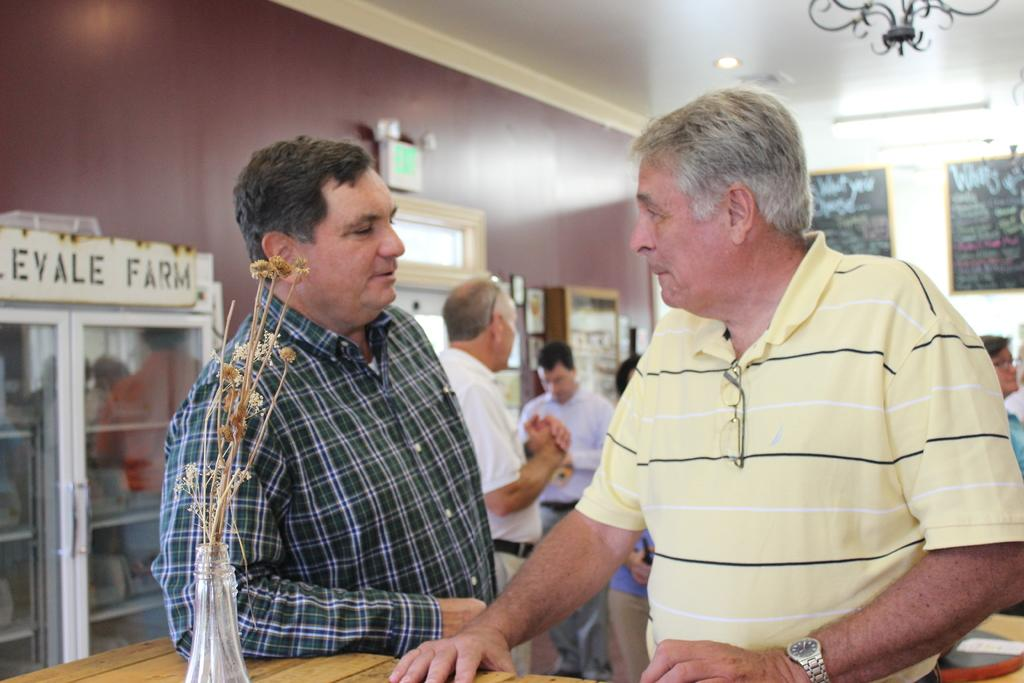How many men are in the foreground of the image? There are two men standing in the foreground of the image. What can be seen on a table in the image? There is an object on a table in the image. What is visible in the background of the image? In the background of the image, there are people, posters, light, showcases, and other objects. Can you describe the objects in the background of the image? The objects in the background of the image include posters, showcases, and other unspecified objects. What type of vegetable is being sung about in the background of the image? There is no vegetable or singing present in the image; it only features people, posters, light, showcases, and other objects in the background. 